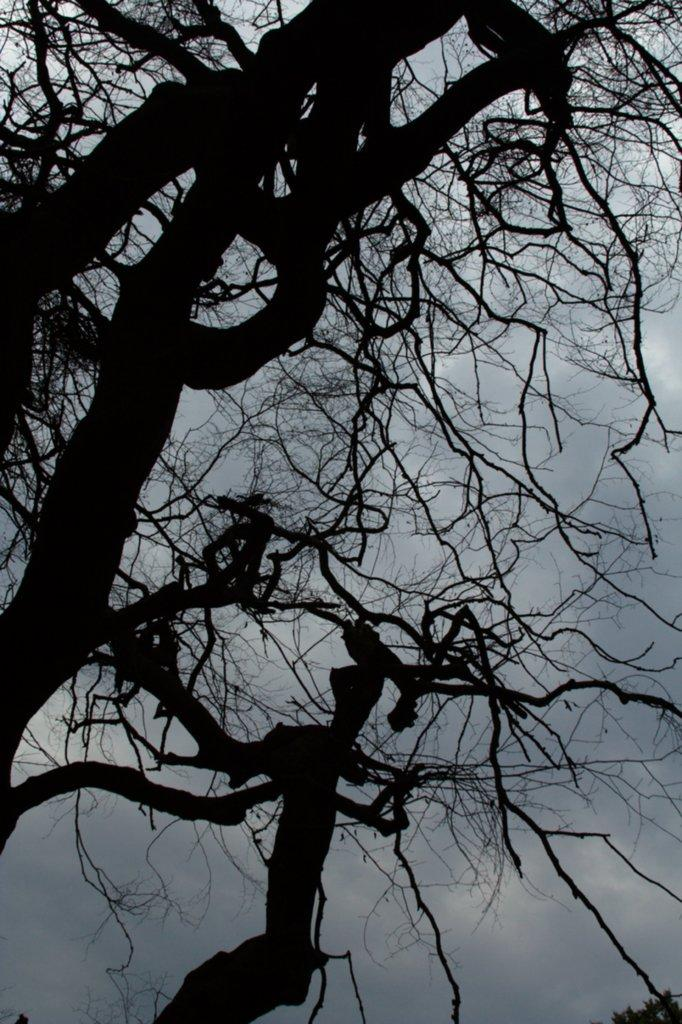What is the main element in the center of the image? The main element in the center of the image is the sky. What can be seen in the sky in the image? Clouds are present in the center of the image. What else is visible in the center of the image besides the sky and clouds? Trees are visible in the center of the image. How many rings are hanging from the trees in the image? There are no rings present in the image; it only features the sky, clouds, and trees. 